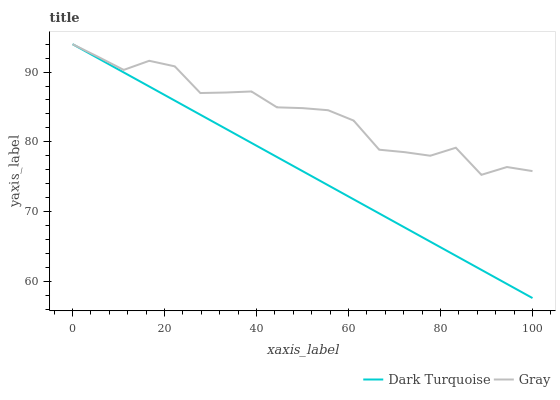Does Gray have the minimum area under the curve?
Answer yes or no. No. Is Gray the smoothest?
Answer yes or no. No. Does Gray have the lowest value?
Answer yes or no. No. 